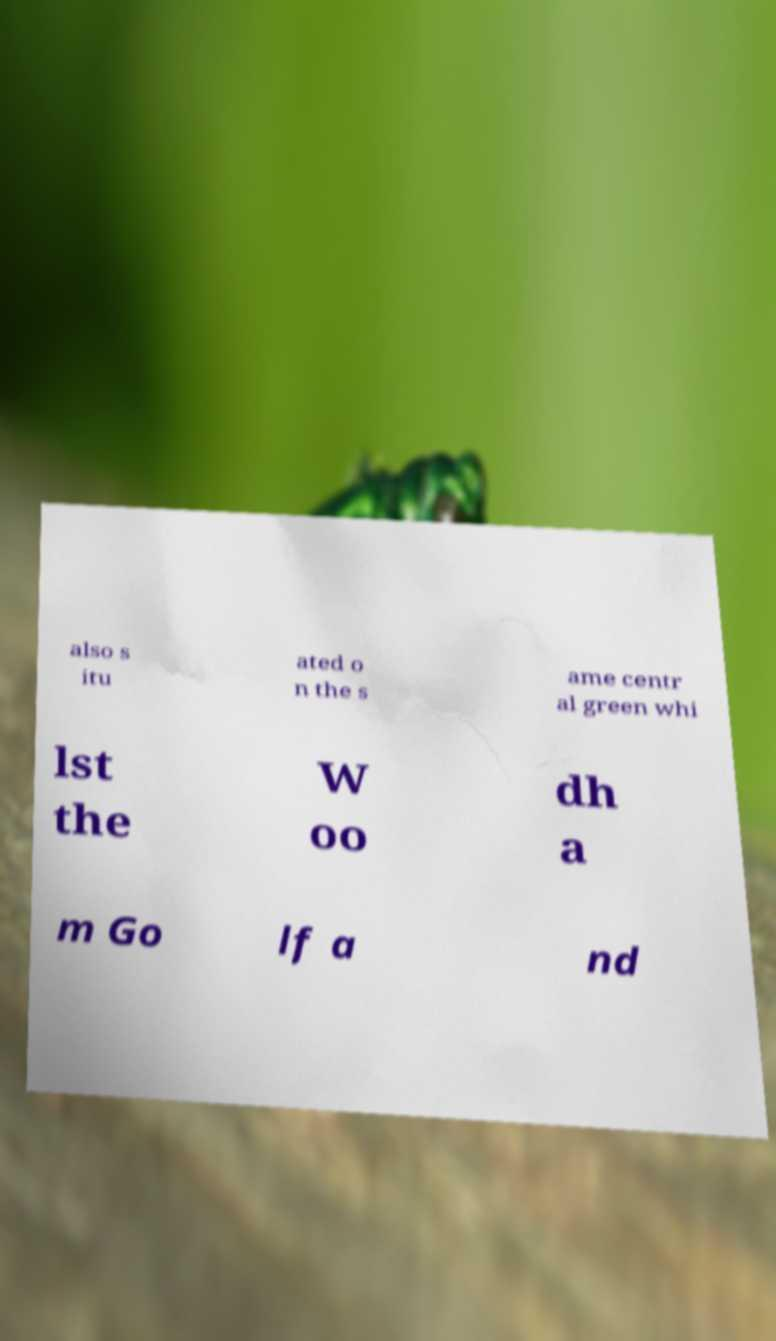Could you assist in decoding the text presented in this image and type it out clearly? also s itu ated o n the s ame centr al green whi lst the W oo dh a m Go lf a nd 